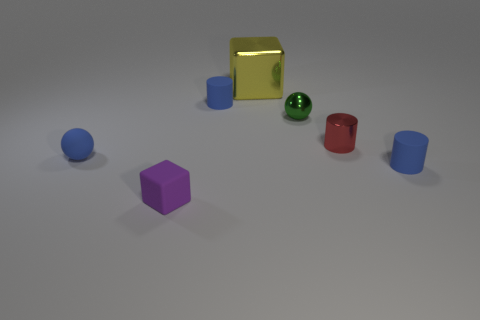How many purple cubes are in front of the small green object behind the small block?
Provide a succinct answer. 1. What number of other objects are there of the same color as the tiny matte block?
Offer a very short reply. 0. What color is the rubber cylinder in front of the small blue rubber object behind the tiny shiny cylinder?
Your answer should be compact. Blue. Are there any things that have the same color as the tiny matte ball?
Your answer should be very brief. Yes. How many metallic objects are either big yellow blocks or small green spheres?
Provide a succinct answer. 2. Is there a big purple ball that has the same material as the big object?
Provide a succinct answer. No. How many cylinders are both to the left of the yellow block and in front of the red metal cylinder?
Ensure brevity in your answer.  0. Is the number of big yellow blocks that are behind the big yellow cube less than the number of matte cylinders that are right of the green ball?
Ensure brevity in your answer.  Yes. Does the large object have the same shape as the tiny purple rubber thing?
Make the answer very short. Yes. What number of other objects are the same size as the red shiny thing?
Your answer should be compact. 5. 